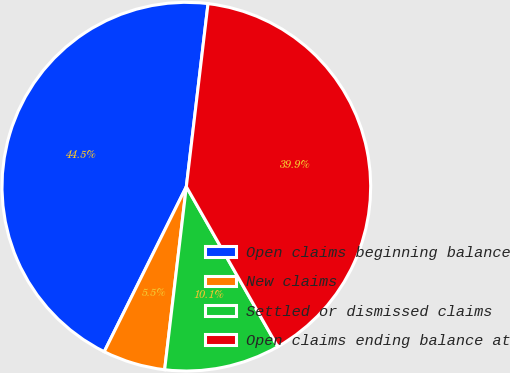Convert chart. <chart><loc_0><loc_0><loc_500><loc_500><pie_chart><fcel>Open claims beginning balance<fcel>New claims<fcel>Settled or dismissed claims<fcel>Open claims ending balance at<nl><fcel>44.53%<fcel>5.47%<fcel>10.14%<fcel>39.86%<nl></chart> 